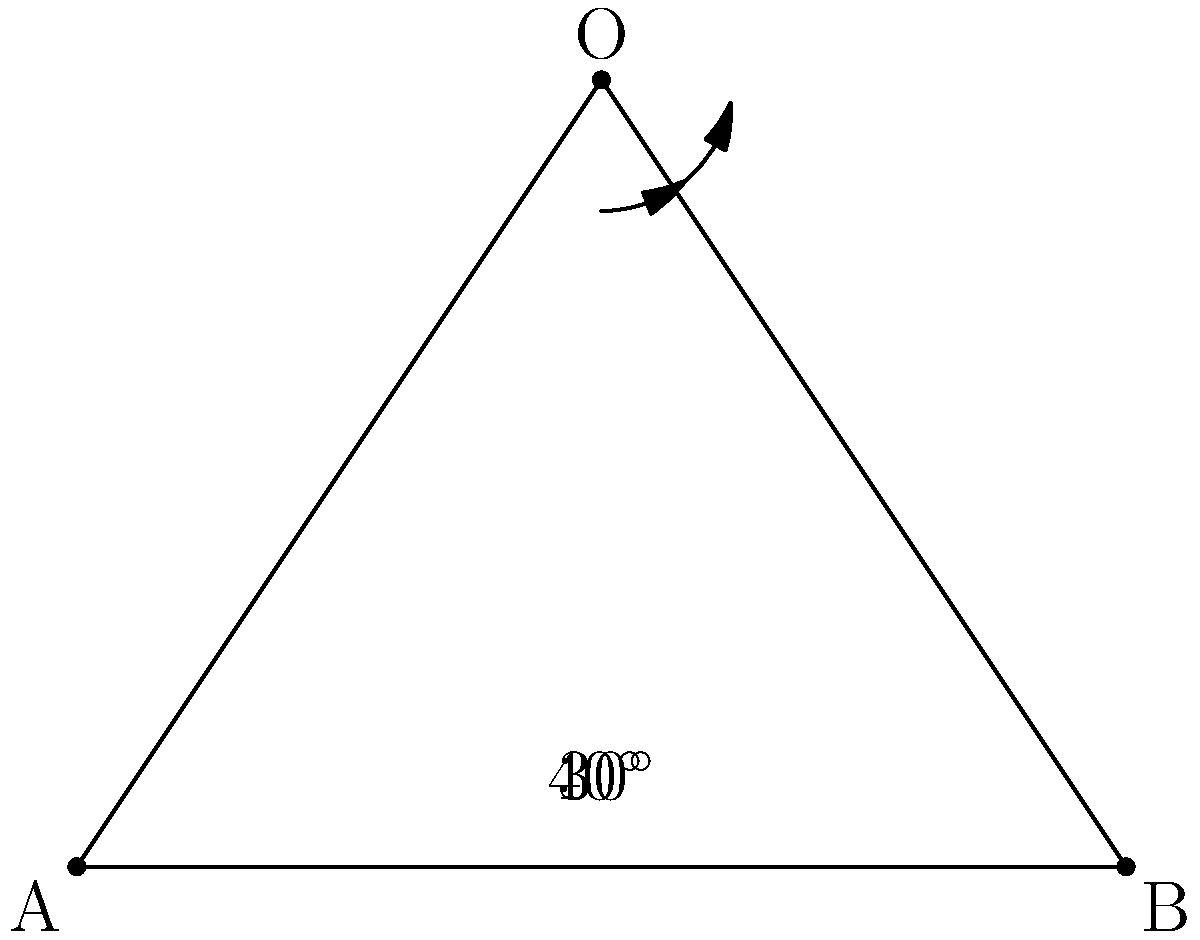An explorer in the Russian Far East observes two mountain peaks from a vantage point. The angle between the first peak and the horizontal is $30^\circ$, while the angle between the second peak and the horizontal is $40^\circ$. What is the angle formed between the two mountain peaks from the observer's position? To find the angle between the two mountain peaks from the observer's position, we can follow these steps:

1) In the diagram, point O represents the observer's position, and points A and B represent the two mountain peaks.

2) The angle between the first peak and the horizontal is given as $30^\circ$.

3) The angle between the second peak and the horizontal is given as $40^\circ$.

4) To find the angle between the two peaks, we need to subtract the smaller angle from the larger angle:

   $40^\circ - 30^\circ = 10^\circ$

5) This difference represents the angle formed between the two mountain peaks from the observer's position.

Therefore, the angle formed between the two mountain peaks from the observer's position is $10^\circ$.
Answer: $10^\circ$ 